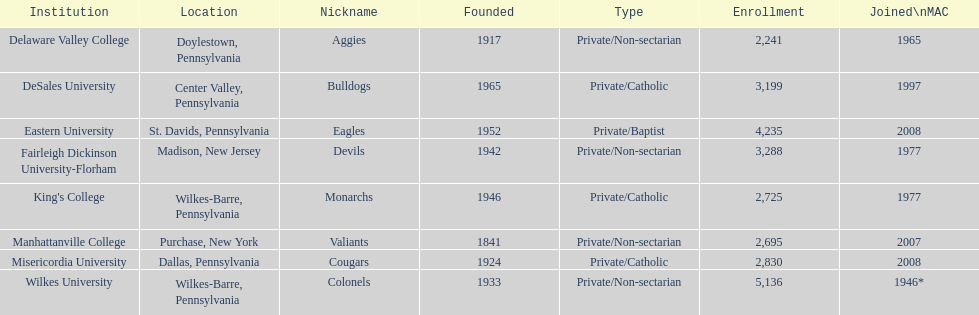What is the total student population at misericordia university? 2,830. 